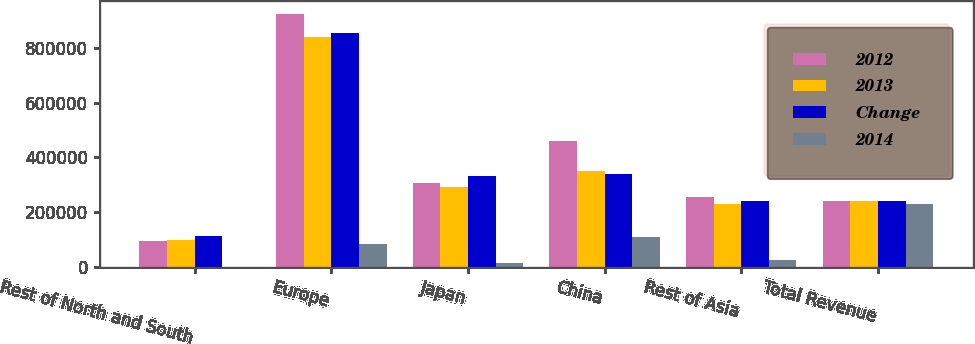Convert chart. <chart><loc_0><loc_0><loc_500><loc_500><stacked_bar_chart><ecel><fcel>Rest of North and South<fcel>Europe<fcel>Japan<fcel>China<fcel>Rest of Asia<fcel>Total Revenue<nl><fcel>2012<fcel>96957<fcel>924477<fcel>308054<fcel>459260<fcel>254471<fcel>240934<nl><fcel>2013<fcel>99215<fcel>840585<fcel>292804<fcel>349575<fcel>230241<fcel>240934<nl><fcel>Change<fcel>114133<fcel>852668<fcel>333558<fcel>341196<fcel>240934<fcel>240934<nl><fcel>2014<fcel>2258<fcel>83892<fcel>15250<fcel>109685<fcel>24230<fcel>231084<nl></chart> 